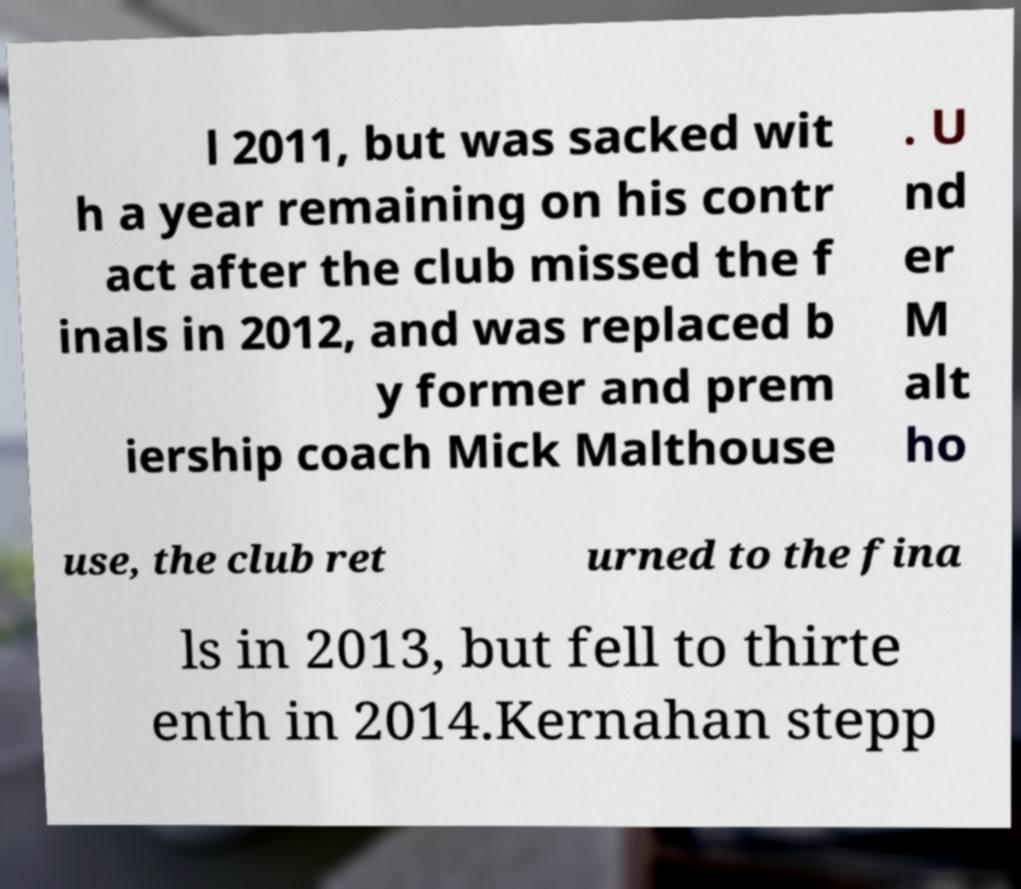Could you assist in decoding the text presented in this image and type it out clearly? l 2011, but was sacked wit h a year remaining on his contr act after the club missed the f inals in 2012, and was replaced b y former and prem iership coach Mick Malthouse . U nd er M alt ho use, the club ret urned to the fina ls in 2013, but fell to thirte enth in 2014.Kernahan stepp 